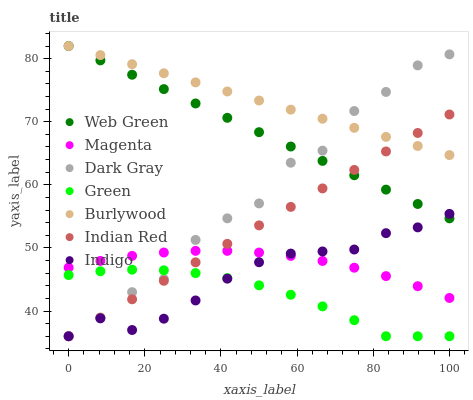Does Green have the minimum area under the curve?
Answer yes or no. Yes. Does Burlywood have the maximum area under the curve?
Answer yes or no. Yes. Does Web Green have the minimum area under the curve?
Answer yes or no. No. Does Web Green have the maximum area under the curve?
Answer yes or no. No. Is Web Green the smoothest?
Answer yes or no. Yes. Is Dark Gray the roughest?
Answer yes or no. Yes. Is Burlywood the smoothest?
Answer yes or no. No. Is Burlywood the roughest?
Answer yes or no. No. Does Indigo have the lowest value?
Answer yes or no. Yes. Does Web Green have the lowest value?
Answer yes or no. No. Does Web Green have the highest value?
Answer yes or no. Yes. Does Dark Gray have the highest value?
Answer yes or no. No. Is Green less than Web Green?
Answer yes or no. Yes. Is Web Green greater than Magenta?
Answer yes or no. Yes. Does Green intersect Dark Gray?
Answer yes or no. Yes. Is Green less than Dark Gray?
Answer yes or no. No. Is Green greater than Dark Gray?
Answer yes or no. No. Does Green intersect Web Green?
Answer yes or no. No. 